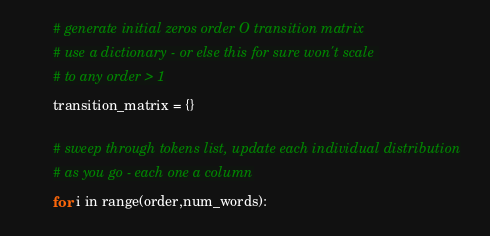Convert code to text. <code><loc_0><loc_0><loc_500><loc_500><_Python_>
        # generate initial zeros order O transition matrix
        # use a dictionary - or else this for sure won't scale 
        # to any order > 1
        transition_matrix = {}

        # sweep through tokens list, update each individual distribution
        # as you go - each one a column
        for i in range(order,num_words):</code> 